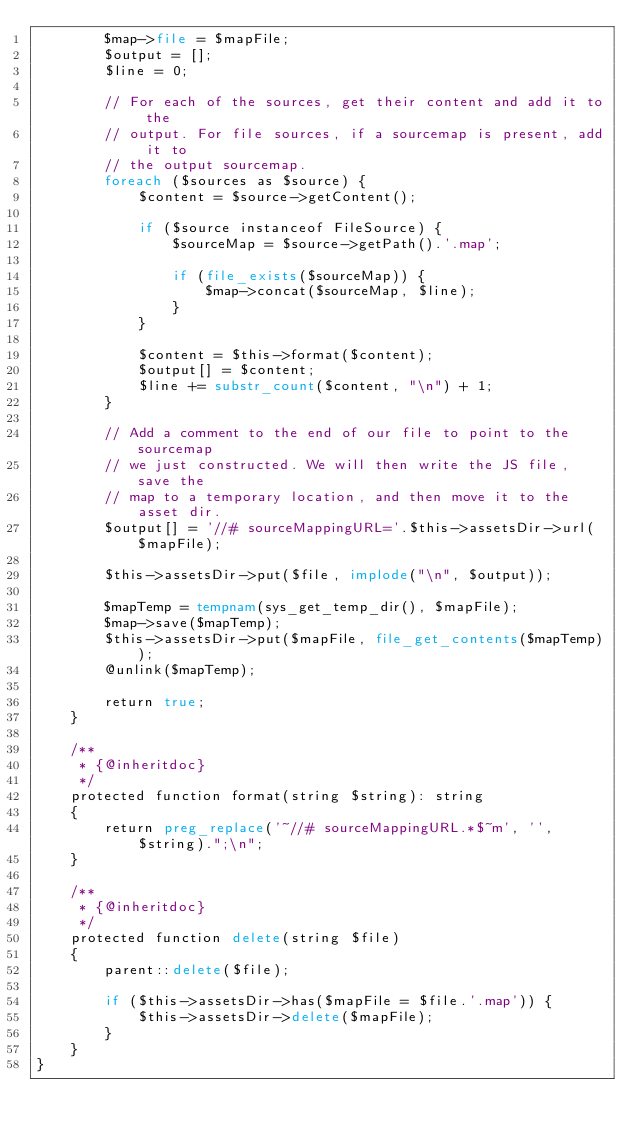<code> <loc_0><loc_0><loc_500><loc_500><_PHP_>        $map->file = $mapFile;
        $output = [];
        $line = 0;

        // For each of the sources, get their content and add it to the
        // output. For file sources, if a sourcemap is present, add it to
        // the output sourcemap.
        foreach ($sources as $source) {
            $content = $source->getContent();

            if ($source instanceof FileSource) {
                $sourceMap = $source->getPath().'.map';

                if (file_exists($sourceMap)) {
                    $map->concat($sourceMap, $line);
                }
            }

            $content = $this->format($content);
            $output[] = $content;
            $line += substr_count($content, "\n") + 1;
        }

        // Add a comment to the end of our file to point to the sourcemap
        // we just constructed. We will then write the JS file, save the
        // map to a temporary location, and then move it to the asset dir.
        $output[] = '//# sourceMappingURL='.$this->assetsDir->url($mapFile);

        $this->assetsDir->put($file, implode("\n", $output));

        $mapTemp = tempnam(sys_get_temp_dir(), $mapFile);
        $map->save($mapTemp);
        $this->assetsDir->put($mapFile, file_get_contents($mapTemp));
        @unlink($mapTemp);

        return true;
    }

    /**
     * {@inheritdoc}
     */
    protected function format(string $string): string
    {
        return preg_replace('~//# sourceMappingURL.*$~m', '', $string).";\n";
    }

    /**
     * {@inheritdoc}
     */
    protected function delete(string $file)
    {
        parent::delete($file);

        if ($this->assetsDir->has($mapFile = $file.'.map')) {
            $this->assetsDir->delete($mapFile);
        }
    }
}
</code> 